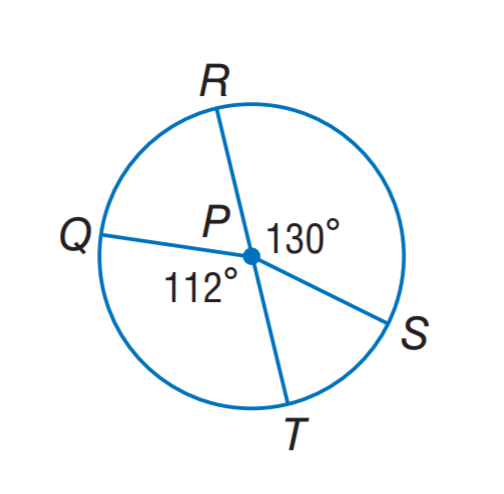Answer the mathemtical geometry problem and directly provide the correct option letter.
Question: In \odot P, P S = 4, find the length of \widehat Q R. Round to the nearest hundredth.
Choices: A: 1.75 B: 2.37 C: 3.49 D: 4.75 D 